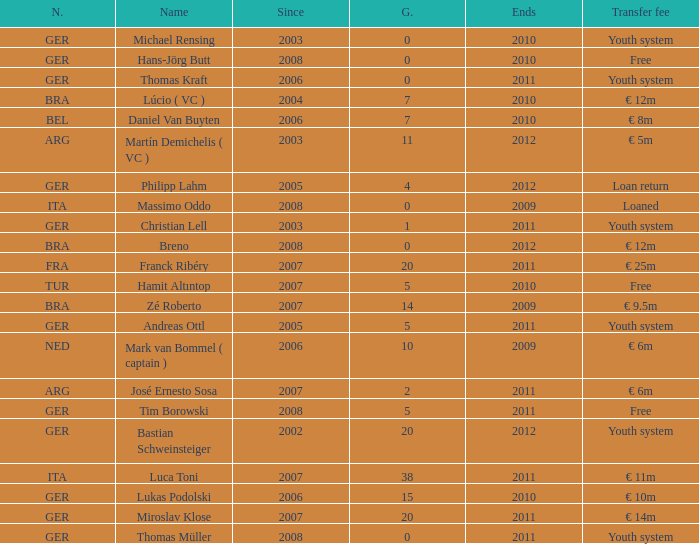What is the lowest year in since that had a transfer fee of € 14m and ended after 2011? None. 